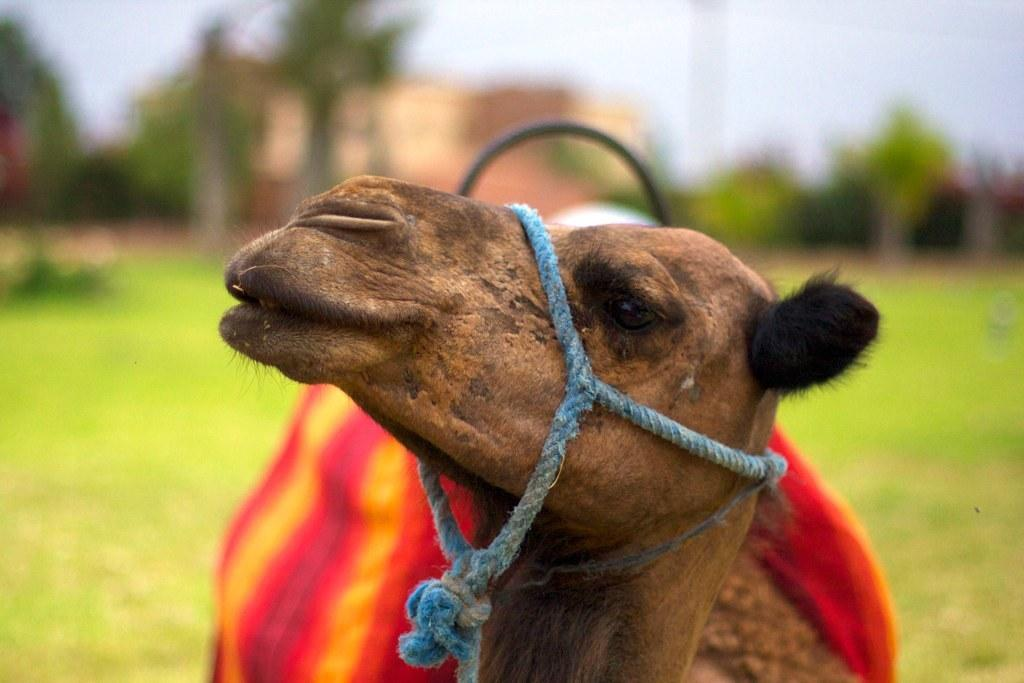What animal is in the front of the image? There is a camel in the front of the image. How would you describe the background of the image? The background of the image appears blurry. What type of vegetation can be seen in the background? There are trees in the background of the image. What is the ground made of in the image? There is grass on the ground in the image. How many frogs are guiding the camel in the image? There are no frogs present in the image, and they are not guiding the camel. 